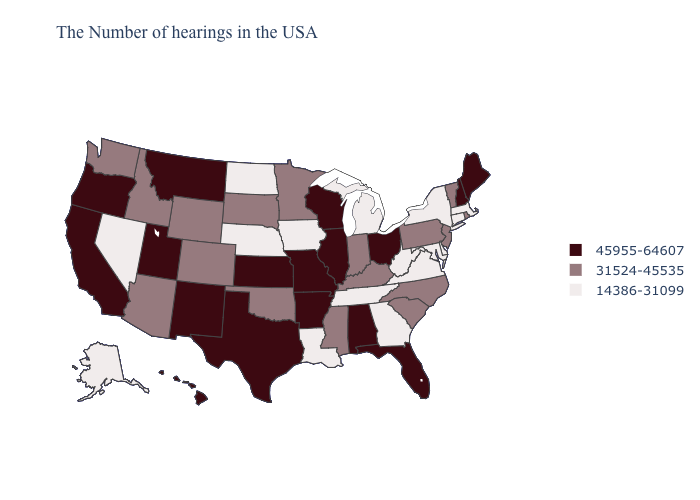What is the value of Alabama?
Write a very short answer. 45955-64607. Does the first symbol in the legend represent the smallest category?
Keep it brief. No. Does the first symbol in the legend represent the smallest category?
Quick response, please. No. Name the states that have a value in the range 31524-45535?
Give a very brief answer. Rhode Island, Vermont, New Jersey, Pennsylvania, North Carolina, South Carolina, Kentucky, Indiana, Mississippi, Minnesota, Oklahoma, South Dakota, Wyoming, Colorado, Arizona, Idaho, Washington. Name the states that have a value in the range 31524-45535?
Keep it brief. Rhode Island, Vermont, New Jersey, Pennsylvania, North Carolina, South Carolina, Kentucky, Indiana, Mississippi, Minnesota, Oklahoma, South Dakota, Wyoming, Colorado, Arizona, Idaho, Washington. Name the states that have a value in the range 31524-45535?
Be succinct. Rhode Island, Vermont, New Jersey, Pennsylvania, North Carolina, South Carolina, Kentucky, Indiana, Mississippi, Minnesota, Oklahoma, South Dakota, Wyoming, Colorado, Arizona, Idaho, Washington. What is the highest value in the USA?
Be succinct. 45955-64607. Name the states that have a value in the range 45955-64607?
Write a very short answer. Maine, New Hampshire, Ohio, Florida, Alabama, Wisconsin, Illinois, Missouri, Arkansas, Kansas, Texas, New Mexico, Utah, Montana, California, Oregon, Hawaii. Name the states that have a value in the range 45955-64607?
Give a very brief answer. Maine, New Hampshire, Ohio, Florida, Alabama, Wisconsin, Illinois, Missouri, Arkansas, Kansas, Texas, New Mexico, Utah, Montana, California, Oregon, Hawaii. What is the value of Wisconsin?
Give a very brief answer. 45955-64607. What is the value of Pennsylvania?
Quick response, please. 31524-45535. What is the value of North Dakota?
Answer briefly. 14386-31099. What is the lowest value in states that border Wisconsin?
Write a very short answer. 14386-31099. What is the value of Indiana?
Give a very brief answer. 31524-45535. Which states have the lowest value in the Northeast?
Short answer required. Massachusetts, Connecticut, New York. 